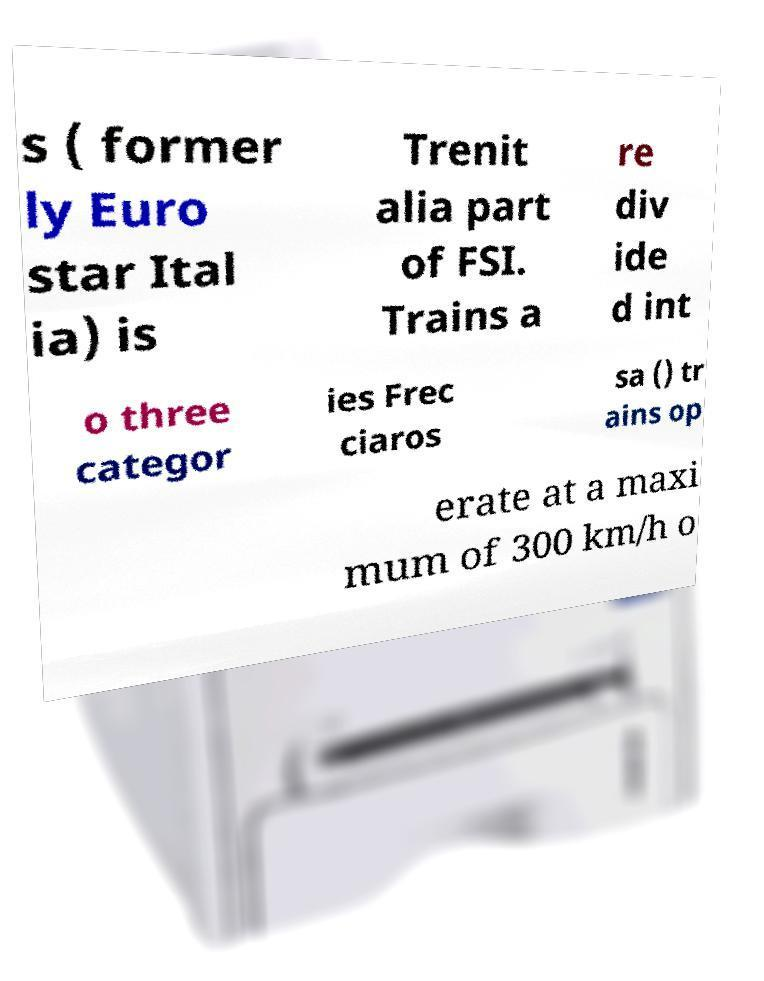Can you accurately transcribe the text from the provided image for me? s ( former ly Euro star Ital ia) is Trenit alia part of FSI. Trains a re div ide d int o three categor ies Frec ciaros sa () tr ains op erate at a maxi mum of 300 km/h o 